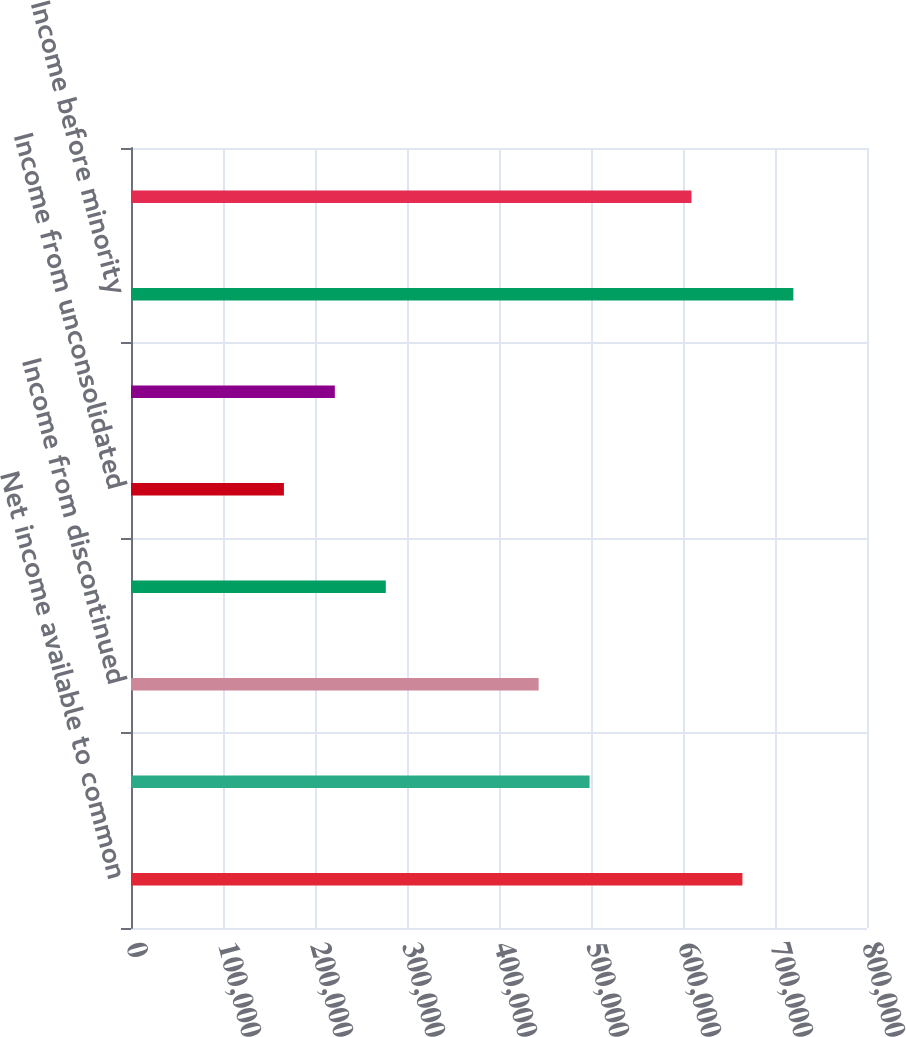Convert chart. <chart><loc_0><loc_0><loc_500><loc_500><bar_chart><fcel>Net income available to common<fcel>Minority interest in Operating<fcel>Income from discontinued<fcel>Gains on sales of real estate<fcel>Income from unconsolidated<fcel>Minority interests in property<fcel>Income before minority<fcel>Real estate depreciation and<nl><fcel>664578<fcel>498454<fcel>443080<fcel>276956<fcel>166207<fcel>221581<fcel>719953<fcel>609204<nl></chart> 